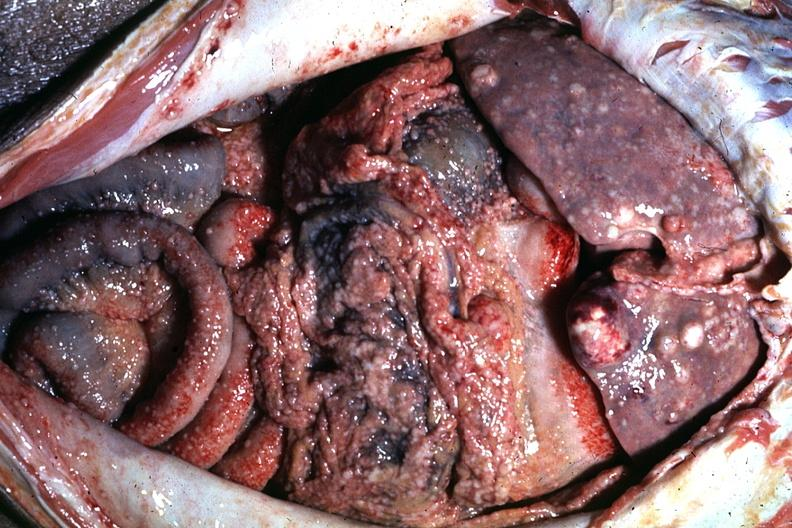s peritoneum present?
Answer the question using a single word or phrase. Yes 